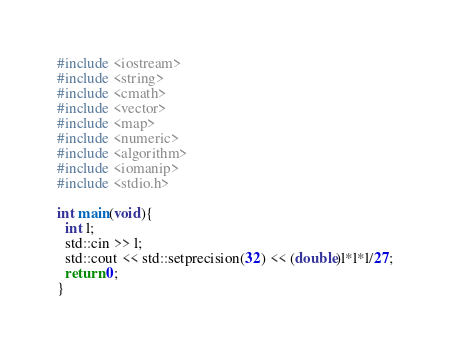Convert code to text. <code><loc_0><loc_0><loc_500><loc_500><_C++_>#include <iostream>
#include <string>
#include <cmath>
#include <vector>
#include <map>
#include <numeric>
#include <algorithm>
#include <iomanip>
#include <stdio.h>

int main(void){
  int l;
  std::cin >> l;
  std::cout << std::setprecision(32) << (double)l*l*l/27;
  return 0;
}</code> 